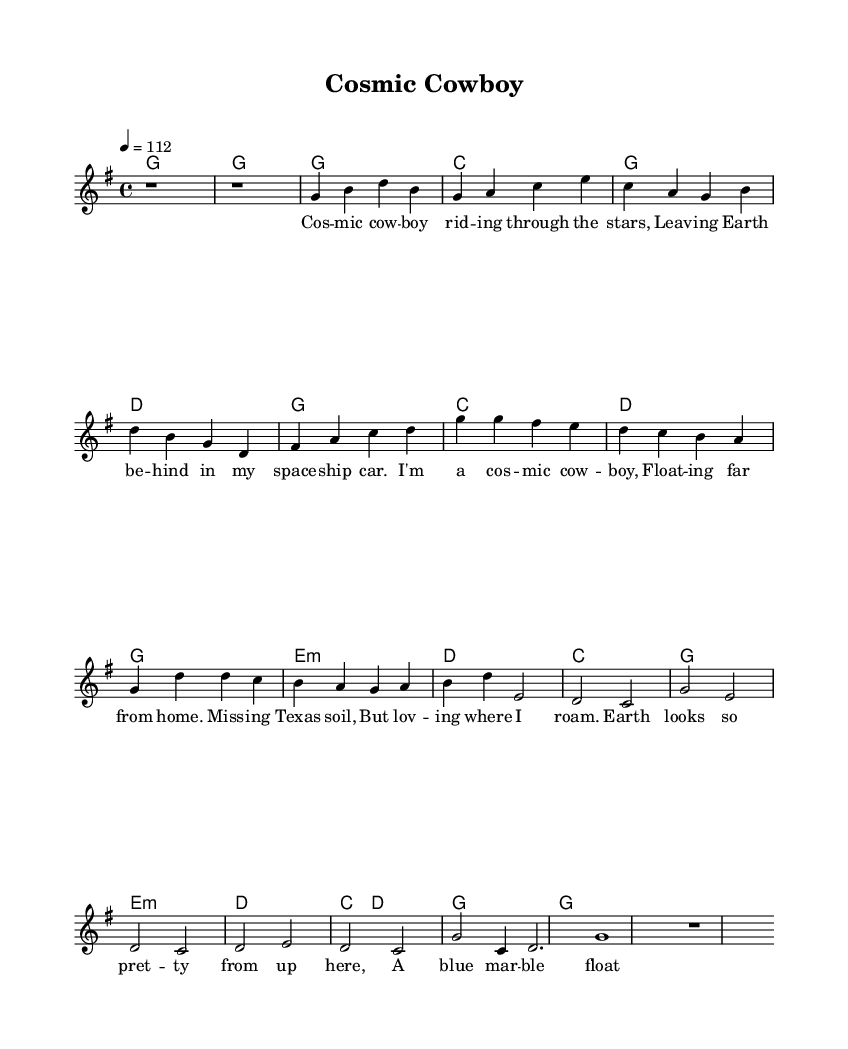What is the key signature of this music? The key signature is G major, which has one sharp. It can be identified at the beginning of the sheet music where the sharp is indicated on the F line.
Answer: G major What is the time signature of this music? The time signature is 4/4, which means there are four beats per measure and the quarter note gets one beat. This is mentioned at the start of the music sheet in the time signature notation.
Answer: 4/4 What is the tempo marking for this piece? The tempo marking is 4 equals 112, indicating a moderately fast pace. This can be found at the beginning of the music score where the tempo is specified.
Answer: 112 How many measures are in the chorus section of the song? The chorus consists of four measures that can be counted directly from the score notation. Each measure corresponds to one complete grouping of four beats indicated by the time signature.
Answer: 4 What is the first note of the verse? The first note of the verse is G. This can be identified by looking at the melodic line starting from the first note of the verse section in the score.
Answer: G What lyrical theme is expressed in the bridge? The bridge expresses a theme of perspective from space, describing Earth as a "blue marble" floating in the void. This is inferred from the lyrics provided in the bridge section and speaks to the feelings of awe and beauty when observing Earth from a distance.
Answer: Perspective What is the rhyme scheme of the chorus lyrics? The rhyme scheme of the chorus follows an AABB pattern, where each pair of lines rhymes with one another. This can be analyzed by reading through the lyrics in the score and noting the end sounds of each line.
Answer: AABB 